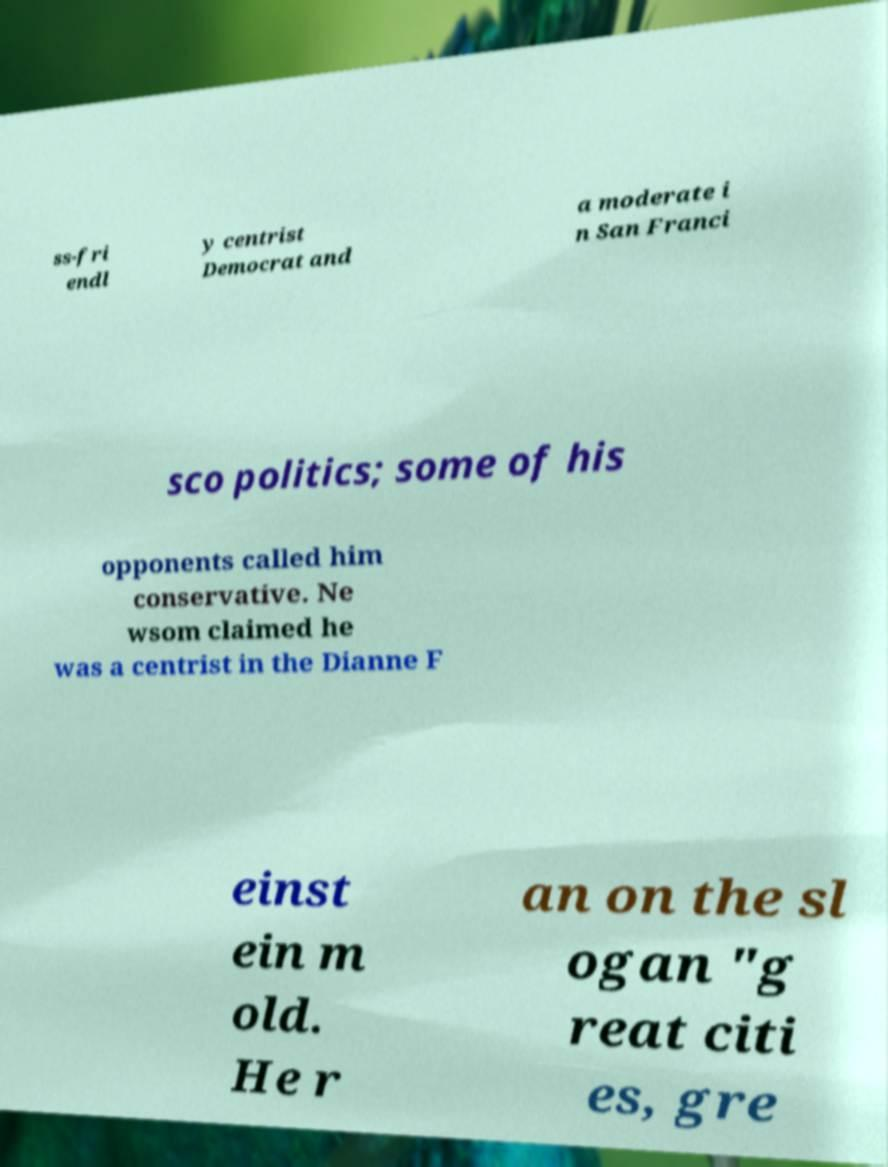Please read and relay the text visible in this image. What does it say? ss-fri endl y centrist Democrat and a moderate i n San Franci sco politics; some of his opponents called him conservative. Ne wsom claimed he was a centrist in the Dianne F einst ein m old. He r an on the sl ogan "g reat citi es, gre 